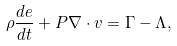Convert formula to latex. <formula><loc_0><loc_0><loc_500><loc_500>\rho \frac { d e } { d t } + P \nabla \cdot v = \Gamma - \Lambda ,</formula> 